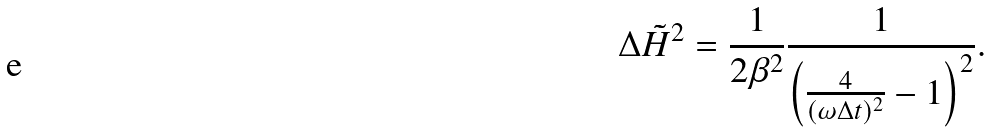Convert formula to latex. <formula><loc_0><loc_0><loc_500><loc_500>\Delta \tilde { H } ^ { 2 } = \frac { 1 } { 2 \beta ^ { 2 } } \frac { 1 } { \left ( \frac { 4 } { ( \omega \Delta t ) ^ { 2 } } - 1 \right ) ^ { 2 } } .</formula> 